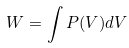Convert formula to latex. <formula><loc_0><loc_0><loc_500><loc_500>W = \int P ( V ) d V</formula> 